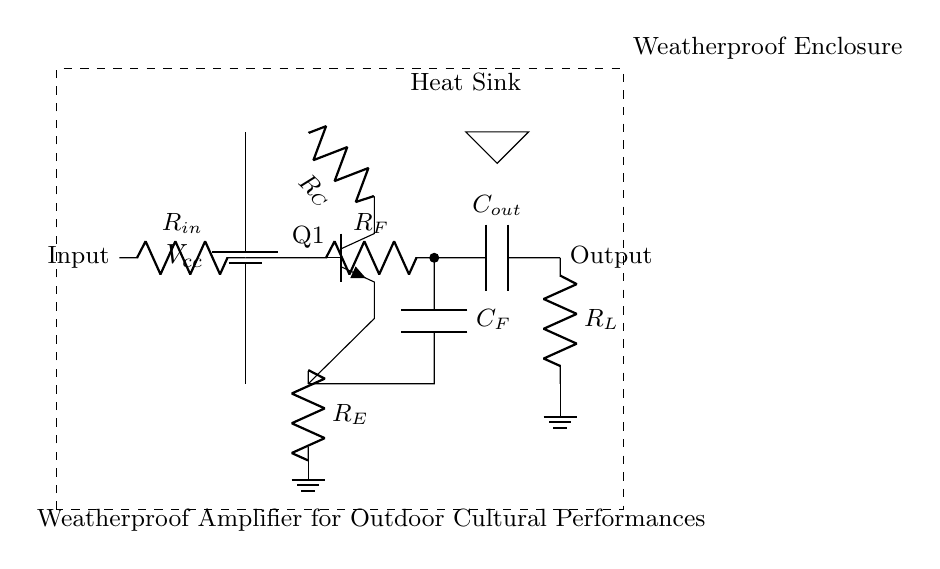What is the function of R_in in the circuit? R_in serves as the input resistor that helps limit the current entering into the amplifier's input stage, thus protecting the subsequent components.
Answer: Input resistor What is the location of the heat sink? The heat sink is located at the top part of the weatherproof enclosure, indicated by a small triangle, which helps dissipate heat generated by the amplifier during operation.
Answer: Top part What type of transistor is used in the circuit? The circuit uses an NPN transistor, which is identified by the labeling in the diagram, indicating its operation mode and configuration in the amplifier.
Answer: NPN How many capacitors are present in the circuit? There are two capacitors present in the circuit: one in the feedback network and one in the output stage, as shown in the corresponding locations in the amplifier schematic.
Answer: Two What does the rectangle around the diagram represent? The dashed rectangle denotes the weatherproof enclosure, indicating that the circuit is designed to operate outdoors and withstand various environmental conditions.
Answer: Weatherproof enclosure What is the purpose of the feedback resistor R_F? The feedback resistor R_F is used to provide a portion of the output signal back to the input, which stabilizes the amplifier's gain and improves linearity in the amplification process.
Answer: Stabilization 